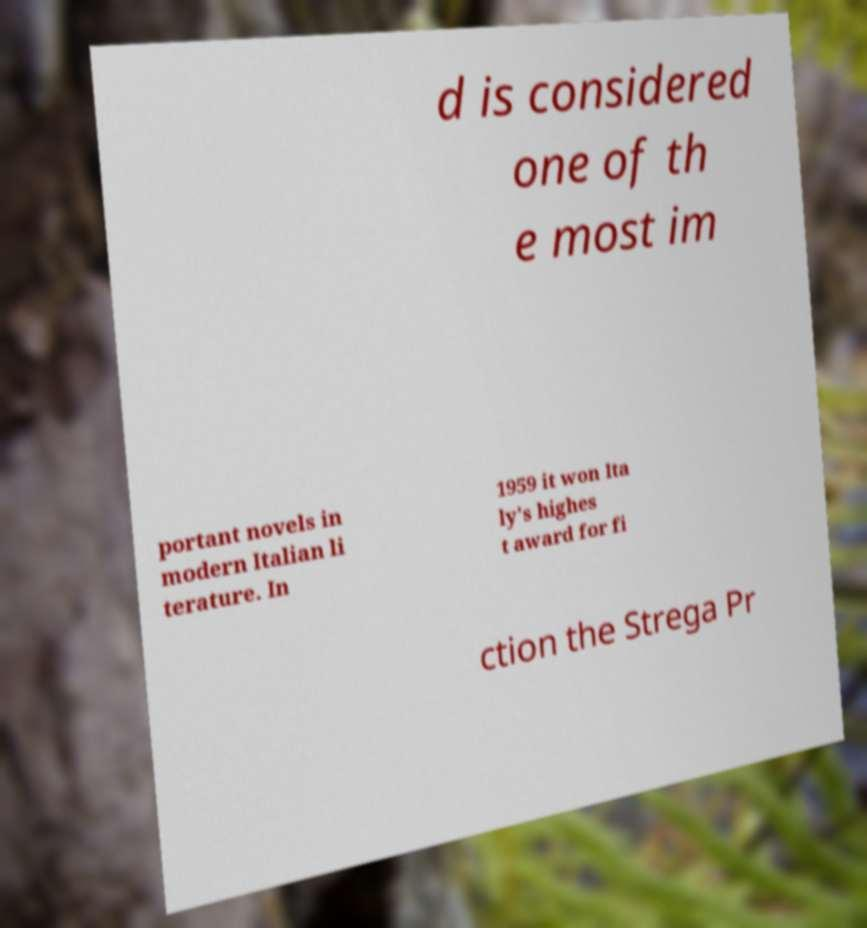Can you accurately transcribe the text from the provided image for me? d is considered one of th e most im portant novels in modern Italian li terature. In 1959 it won Ita ly's highes t award for fi ction the Strega Pr 